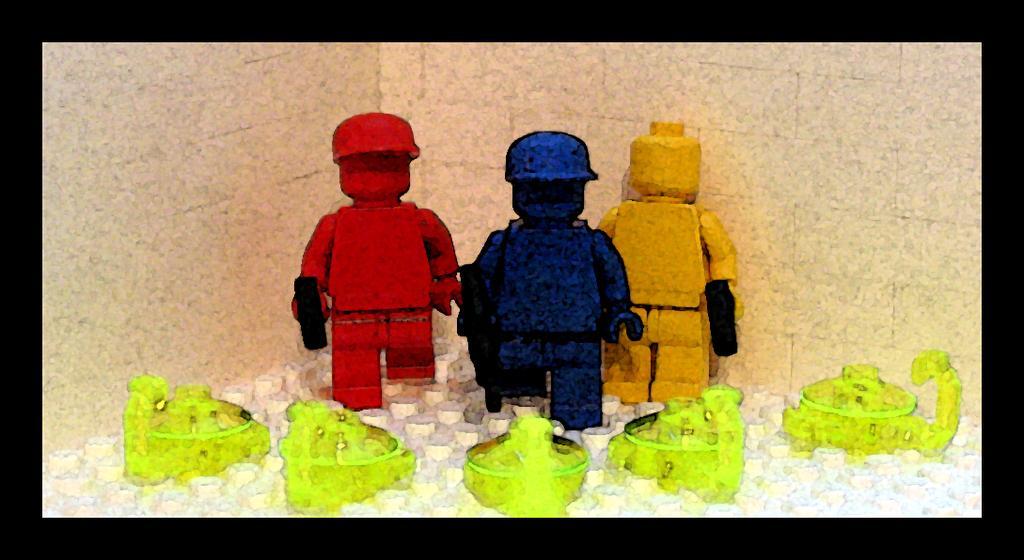Describe this image in one or two sentences. In this picture, we see three toys which are in red, blue and yellow color. Behind that, we see a wall. In front of the toys, we see five things which looks like boxes. These boxes are in green color. 